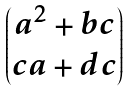Convert formula to latex. <formula><loc_0><loc_0><loc_500><loc_500>\begin{pmatrix} a ^ { 2 } + b c \\ c a + d c \end{pmatrix}</formula> 